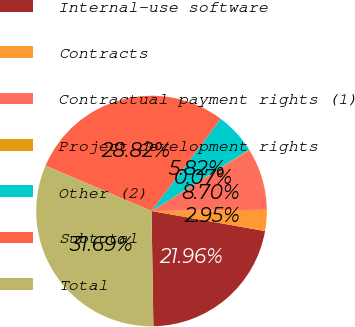Convert chart to OTSL. <chart><loc_0><loc_0><loc_500><loc_500><pie_chart><fcel>Internal-use software<fcel>Contracts<fcel>Contractual payment rights (1)<fcel>Project development rights<fcel>Other (2)<fcel>Subtotal<fcel>Total<nl><fcel>21.96%<fcel>2.95%<fcel>8.7%<fcel>0.07%<fcel>5.82%<fcel>28.82%<fcel>31.69%<nl></chart> 